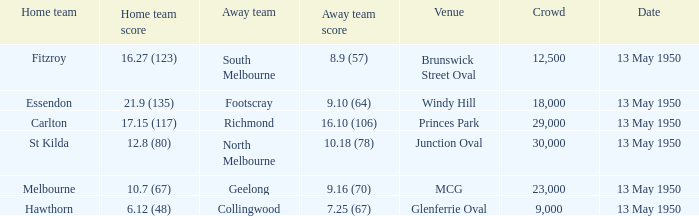What was the away team's score when Fitzroy's score was 16.27 (123) on May 13, 1950. 8.9 (57). 